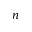Convert formula to latex. <formula><loc_0><loc_0><loc_500><loc_500>n</formula> 